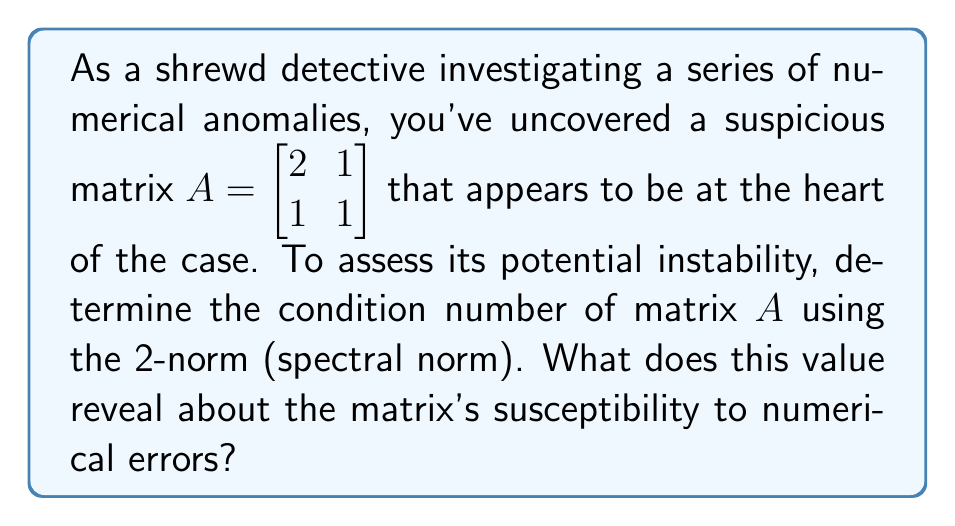Can you solve this math problem? To determine the condition number of matrix $A$ using the 2-norm, we follow these steps:

1. Calculate the eigenvalues of $A$:
   Characteristic equation: $\det(A - \lambda I) = 0$
   $\begin{vmatrix} 2-\lambda & 1 \\ 1 & 1-\lambda \end{vmatrix} = 0$
   $(2-\lambda)(1-\lambda) - 1 = 0$
   $\lambda^2 - 3\lambda + 1 = 0$
   Solving this quadratic equation yields:
   $\lambda_1 = \frac{3+\sqrt{5}}{2}$ and $\lambda_2 = \frac{3-\sqrt{5}}{2}$

2. The 2-norm of $A$ is the largest singular value, which for a symmetric matrix is the largest absolute eigenvalue:
   $\|A\|_2 = \max(|\lambda_1|, |\lambda_2|) = \frac{3+\sqrt{5}}{2}$

3. Calculate $A^{-1}$:
   $A^{-1} = \frac{1}{\det(A)} \begin{bmatrix} 1 & -1 \\ -1 & 2 \end{bmatrix} = \begin{bmatrix} 1 & -1 \\ -1 & 2 \end{bmatrix}$

4. Calculate the eigenvalues of $A^{-1}$ using the same method as step 1:
   $\lambda_1' = \frac{3+\sqrt{5}}{2}$ and $\lambda_2' = \frac{3-\sqrt{5}}{2}$

5. The 2-norm of $A^{-1}$ is:
   $\|A^{-1}\|_2 = \max(|\lambda_1'|, |\lambda_2'|) = \frac{3+\sqrt{5}}{2}$

6. The condition number is:
   $\kappa(A) = \|A\|_2 \cdot \|A^{-1}\|_2 = (\frac{3+\sqrt{5}}{2})^2 = \frac{11+5\sqrt{5}}{2} \approx 8.472$

This condition number indicates that the matrix is moderately ill-conditioned. It suggests that small changes in the input could lead to relatively large changes in the output, making the matrix somewhat susceptible to numerical errors in computations.
Answer: $\kappa(A) = \frac{11+5\sqrt{5}}{2} \approx 8.472$ 